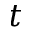<formula> <loc_0><loc_0><loc_500><loc_500>t</formula> 